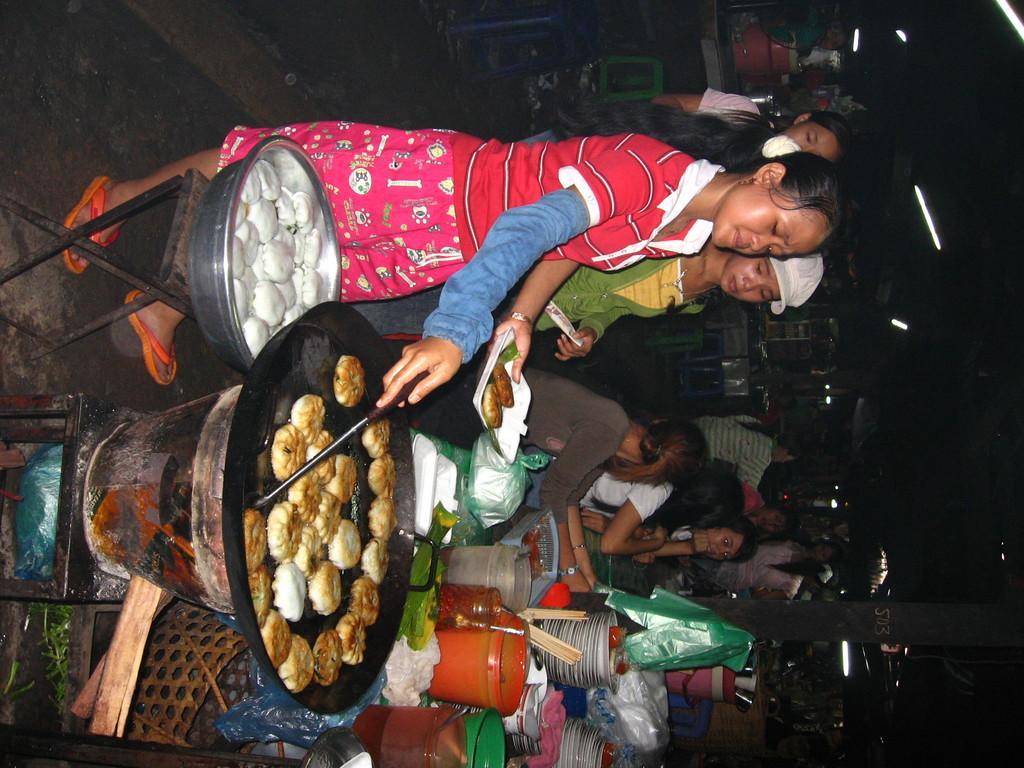In one or two sentences, can you explain what this image depicts? In this image there is a woman holding a spoon and cooking the food which is in the pan. Pan is on the stove. Beside woman there is a table having a bowl which is having food in it. Few persons are sitting before a table having few bottles, plates, jars and few objects on it. There are few lights. Behind the persons there are few buildings. 